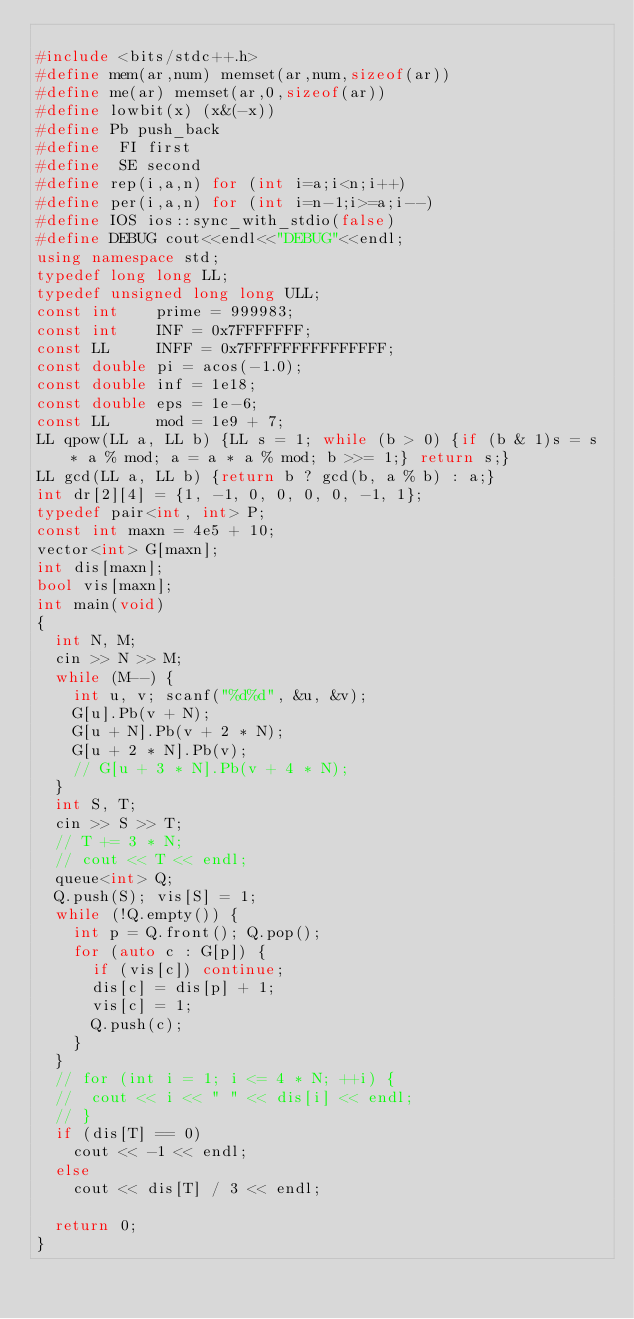<code> <loc_0><loc_0><loc_500><loc_500><_C++_>
#include <bits/stdc++.h>
#define mem(ar,num) memset(ar,num,sizeof(ar))
#define me(ar) memset(ar,0,sizeof(ar))
#define lowbit(x) (x&(-x))
#define Pb push_back
#define  FI first
#define  SE second
#define rep(i,a,n) for (int i=a;i<n;i++)
#define per(i,a,n) for (int i=n-1;i>=a;i--)
#define IOS ios::sync_with_stdio(false)
#define DEBUG cout<<endl<<"DEBUG"<<endl;
using namespace std;
typedef long long LL;
typedef unsigned long long ULL;
const int    prime = 999983;
const int    INF = 0x7FFFFFFF;
const LL     INFF = 0x7FFFFFFFFFFFFFFF;
const double pi = acos(-1.0);
const double inf = 1e18;
const double eps = 1e-6;
const LL     mod = 1e9 + 7;
LL qpow(LL a, LL b) {LL s = 1; while (b > 0) {if (b & 1)s = s * a % mod; a = a * a % mod; b >>= 1;} return s;}
LL gcd(LL a, LL b) {return b ? gcd(b, a % b) : a;}
int dr[2][4] = {1, -1, 0, 0, 0, 0, -1, 1};
typedef pair<int, int> P;
const int maxn = 4e5 + 10;
vector<int> G[maxn];
int dis[maxn];
bool vis[maxn];
int main(void)
{
	int N, M;
	cin >> N >> M;
	while (M--) {
		int u, v; scanf("%d%d", &u, &v);
		G[u].Pb(v + N);
		G[u + N].Pb(v + 2 * N);
		G[u + 2 * N].Pb(v);
		// G[u + 3 * N].Pb(v + 4 * N);
	}
	int S, T;
	cin >> S >> T;
	// T += 3 * N;
	// cout << T << endl;
	queue<int> Q;
	Q.push(S); vis[S] = 1;
	while (!Q.empty()) {
		int p = Q.front(); Q.pop();
		for (auto c : G[p]) {
			if (vis[c]) continue;
			dis[c] = dis[p] + 1;
			vis[c] = 1;
			Q.push(c);
		}
	}
	// for (int i = 1; i <= 4 * N; ++i) {
	// 	cout << i << " " << dis[i] << endl;
	// }
	if (dis[T] == 0)
		cout << -1 << endl;
	else
		cout << dis[T] / 3 << endl;

	return 0;
}</code> 